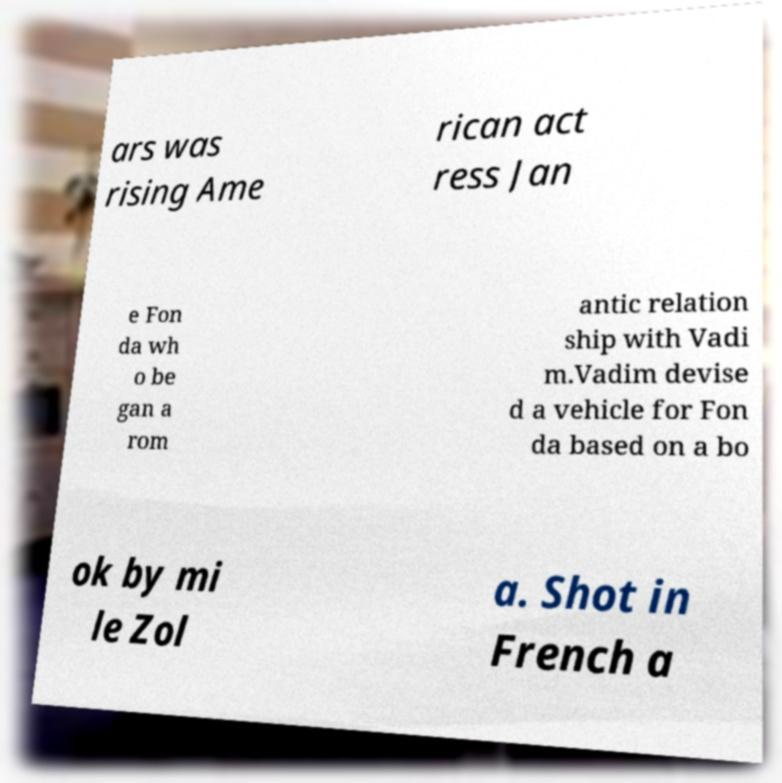Could you extract and type out the text from this image? ars was rising Ame rican act ress Jan e Fon da wh o be gan a rom antic relation ship with Vadi m.Vadim devise d a vehicle for Fon da based on a bo ok by mi le Zol a. Shot in French a 